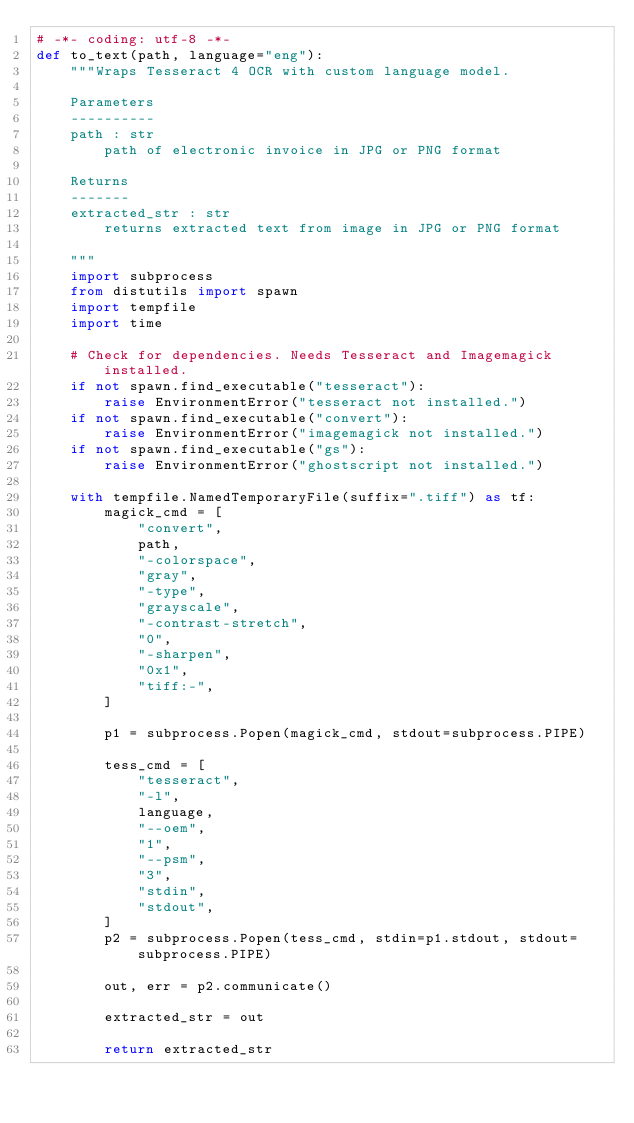<code> <loc_0><loc_0><loc_500><loc_500><_Python_># -*- coding: utf-8 -*-
def to_text(path, language="eng"):
    """Wraps Tesseract 4 OCR with custom language model.

    Parameters
    ----------
    path : str
        path of electronic invoice in JPG or PNG format

    Returns
    -------
    extracted_str : str
        returns extracted text from image in JPG or PNG format

    """
    import subprocess
    from distutils import spawn
    import tempfile
    import time

    # Check for dependencies. Needs Tesseract and Imagemagick installed.
    if not spawn.find_executable("tesseract"):
        raise EnvironmentError("tesseract not installed.")
    if not spawn.find_executable("convert"):
        raise EnvironmentError("imagemagick not installed.")
    if not spawn.find_executable("gs"):
        raise EnvironmentError("ghostscript not installed.")

    with tempfile.NamedTemporaryFile(suffix=".tiff") as tf:
        magick_cmd = [
            "convert",
            path,
            "-colorspace",
            "gray",
            "-type",
            "grayscale",
            "-contrast-stretch",
            "0",
            "-sharpen",
            "0x1",
            "tiff:-",
        ]

        p1 = subprocess.Popen(magick_cmd, stdout=subprocess.PIPE)

        tess_cmd = [
            "tesseract",
            "-l",
            language,
            "--oem",
            "1",
            "--psm",
            "3",
            "stdin",
            "stdout",
        ]
        p2 = subprocess.Popen(tess_cmd, stdin=p1.stdout, stdout=subprocess.PIPE)

        out, err = p2.communicate()

        extracted_str = out

        return extracted_str
</code> 